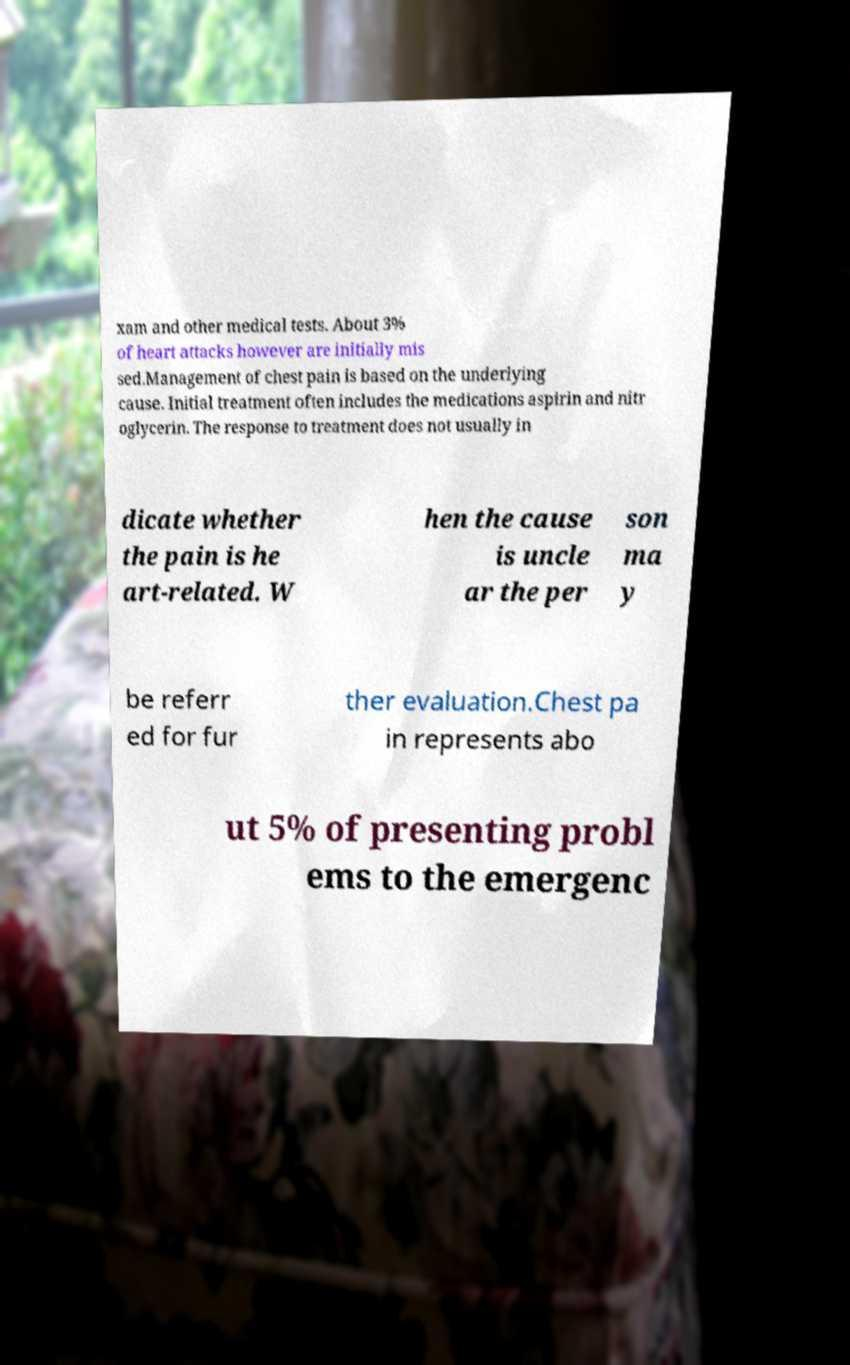For documentation purposes, I need the text within this image transcribed. Could you provide that? xam and other medical tests. About 3% of heart attacks however are initially mis sed.Management of chest pain is based on the underlying cause. Initial treatment often includes the medications aspirin and nitr oglycerin. The response to treatment does not usually in dicate whether the pain is he art-related. W hen the cause is uncle ar the per son ma y be referr ed for fur ther evaluation.Chest pa in represents abo ut 5% of presenting probl ems to the emergenc 